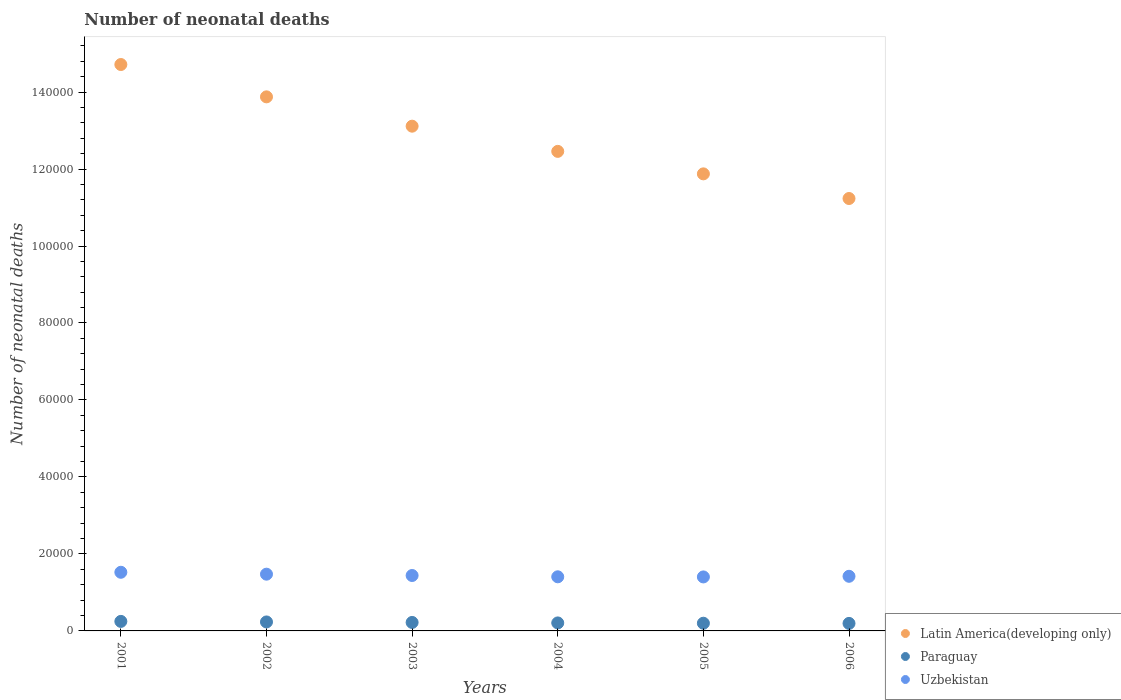How many different coloured dotlines are there?
Make the answer very short. 3. Is the number of dotlines equal to the number of legend labels?
Your answer should be compact. Yes. What is the number of neonatal deaths in in Latin America(developing only) in 2002?
Your answer should be very brief. 1.39e+05. Across all years, what is the maximum number of neonatal deaths in in Uzbekistan?
Your answer should be compact. 1.52e+04. Across all years, what is the minimum number of neonatal deaths in in Latin America(developing only)?
Keep it short and to the point. 1.12e+05. In which year was the number of neonatal deaths in in Paraguay minimum?
Offer a terse response. 2006. What is the total number of neonatal deaths in in Latin America(developing only) in the graph?
Provide a succinct answer. 7.73e+05. What is the difference between the number of neonatal deaths in in Paraguay in 2001 and that in 2002?
Your answer should be very brief. 142. What is the difference between the number of neonatal deaths in in Paraguay in 2003 and the number of neonatal deaths in in Latin America(developing only) in 2001?
Your response must be concise. -1.45e+05. What is the average number of neonatal deaths in in Paraguay per year?
Your answer should be very brief. 2172.33. In the year 2004, what is the difference between the number of neonatal deaths in in Paraguay and number of neonatal deaths in in Uzbekistan?
Offer a very short reply. -1.20e+04. What is the ratio of the number of neonatal deaths in in Latin America(developing only) in 2002 to that in 2006?
Provide a succinct answer. 1.24. Is the number of neonatal deaths in in Latin America(developing only) in 2004 less than that in 2006?
Give a very brief answer. No. Is the difference between the number of neonatal deaths in in Paraguay in 2002 and 2004 greater than the difference between the number of neonatal deaths in in Uzbekistan in 2002 and 2004?
Keep it short and to the point. No. What is the difference between the highest and the second highest number of neonatal deaths in in Uzbekistan?
Provide a short and direct response. 493. What is the difference between the highest and the lowest number of neonatal deaths in in Uzbekistan?
Make the answer very short. 1208. In how many years, is the number of neonatal deaths in in Uzbekistan greater than the average number of neonatal deaths in in Uzbekistan taken over all years?
Your answer should be compact. 2. Is the sum of the number of neonatal deaths in in Paraguay in 2005 and 2006 greater than the maximum number of neonatal deaths in in Latin America(developing only) across all years?
Your answer should be very brief. No. Is it the case that in every year, the sum of the number of neonatal deaths in in Uzbekistan and number of neonatal deaths in in Latin America(developing only)  is greater than the number of neonatal deaths in in Paraguay?
Make the answer very short. Yes. Is the number of neonatal deaths in in Paraguay strictly greater than the number of neonatal deaths in in Latin America(developing only) over the years?
Give a very brief answer. No. Is the number of neonatal deaths in in Uzbekistan strictly less than the number of neonatal deaths in in Paraguay over the years?
Make the answer very short. No. What is the difference between two consecutive major ticks on the Y-axis?
Keep it short and to the point. 2.00e+04. Where does the legend appear in the graph?
Provide a short and direct response. Bottom right. How are the legend labels stacked?
Offer a very short reply. Vertical. What is the title of the graph?
Make the answer very short. Number of neonatal deaths. What is the label or title of the X-axis?
Your answer should be compact. Years. What is the label or title of the Y-axis?
Your answer should be compact. Number of neonatal deaths. What is the Number of neonatal deaths of Latin America(developing only) in 2001?
Provide a short and direct response. 1.47e+05. What is the Number of neonatal deaths of Paraguay in 2001?
Ensure brevity in your answer.  2473. What is the Number of neonatal deaths of Uzbekistan in 2001?
Make the answer very short. 1.52e+04. What is the Number of neonatal deaths of Latin America(developing only) in 2002?
Your response must be concise. 1.39e+05. What is the Number of neonatal deaths of Paraguay in 2002?
Your answer should be compact. 2331. What is the Number of neonatal deaths in Uzbekistan in 2002?
Your answer should be compact. 1.47e+04. What is the Number of neonatal deaths of Latin America(developing only) in 2003?
Provide a succinct answer. 1.31e+05. What is the Number of neonatal deaths of Paraguay in 2003?
Your response must be concise. 2201. What is the Number of neonatal deaths of Uzbekistan in 2003?
Make the answer very short. 1.44e+04. What is the Number of neonatal deaths in Latin America(developing only) in 2004?
Keep it short and to the point. 1.25e+05. What is the Number of neonatal deaths of Paraguay in 2004?
Offer a terse response. 2077. What is the Number of neonatal deaths in Uzbekistan in 2004?
Make the answer very short. 1.41e+04. What is the Number of neonatal deaths of Latin America(developing only) in 2005?
Your response must be concise. 1.19e+05. What is the Number of neonatal deaths of Paraguay in 2005?
Keep it short and to the point. 1998. What is the Number of neonatal deaths of Uzbekistan in 2005?
Provide a succinct answer. 1.40e+04. What is the Number of neonatal deaths of Latin America(developing only) in 2006?
Provide a succinct answer. 1.12e+05. What is the Number of neonatal deaths in Paraguay in 2006?
Ensure brevity in your answer.  1954. What is the Number of neonatal deaths of Uzbekistan in 2006?
Provide a short and direct response. 1.42e+04. Across all years, what is the maximum Number of neonatal deaths in Latin America(developing only)?
Keep it short and to the point. 1.47e+05. Across all years, what is the maximum Number of neonatal deaths of Paraguay?
Ensure brevity in your answer.  2473. Across all years, what is the maximum Number of neonatal deaths of Uzbekistan?
Ensure brevity in your answer.  1.52e+04. Across all years, what is the minimum Number of neonatal deaths of Latin America(developing only)?
Offer a terse response. 1.12e+05. Across all years, what is the minimum Number of neonatal deaths in Paraguay?
Offer a very short reply. 1954. Across all years, what is the minimum Number of neonatal deaths in Uzbekistan?
Offer a very short reply. 1.40e+04. What is the total Number of neonatal deaths of Latin America(developing only) in the graph?
Give a very brief answer. 7.73e+05. What is the total Number of neonatal deaths in Paraguay in the graph?
Provide a succinct answer. 1.30e+04. What is the total Number of neonatal deaths in Uzbekistan in the graph?
Give a very brief answer. 8.67e+04. What is the difference between the Number of neonatal deaths of Latin America(developing only) in 2001 and that in 2002?
Give a very brief answer. 8401. What is the difference between the Number of neonatal deaths in Paraguay in 2001 and that in 2002?
Offer a terse response. 142. What is the difference between the Number of neonatal deaths of Uzbekistan in 2001 and that in 2002?
Your answer should be compact. 493. What is the difference between the Number of neonatal deaths of Latin America(developing only) in 2001 and that in 2003?
Provide a succinct answer. 1.60e+04. What is the difference between the Number of neonatal deaths in Paraguay in 2001 and that in 2003?
Your answer should be very brief. 272. What is the difference between the Number of neonatal deaths in Uzbekistan in 2001 and that in 2003?
Your answer should be very brief. 838. What is the difference between the Number of neonatal deaths in Latin America(developing only) in 2001 and that in 2004?
Ensure brevity in your answer.  2.26e+04. What is the difference between the Number of neonatal deaths of Paraguay in 2001 and that in 2004?
Ensure brevity in your answer.  396. What is the difference between the Number of neonatal deaths of Uzbekistan in 2001 and that in 2004?
Your response must be concise. 1176. What is the difference between the Number of neonatal deaths in Latin America(developing only) in 2001 and that in 2005?
Your answer should be very brief. 2.84e+04. What is the difference between the Number of neonatal deaths of Paraguay in 2001 and that in 2005?
Your answer should be compact. 475. What is the difference between the Number of neonatal deaths of Uzbekistan in 2001 and that in 2005?
Your answer should be compact. 1208. What is the difference between the Number of neonatal deaths of Latin America(developing only) in 2001 and that in 2006?
Offer a terse response. 3.48e+04. What is the difference between the Number of neonatal deaths in Paraguay in 2001 and that in 2006?
Offer a terse response. 519. What is the difference between the Number of neonatal deaths in Uzbekistan in 2001 and that in 2006?
Keep it short and to the point. 1044. What is the difference between the Number of neonatal deaths of Latin America(developing only) in 2002 and that in 2003?
Your response must be concise. 7619. What is the difference between the Number of neonatal deaths in Paraguay in 2002 and that in 2003?
Keep it short and to the point. 130. What is the difference between the Number of neonatal deaths of Uzbekistan in 2002 and that in 2003?
Make the answer very short. 345. What is the difference between the Number of neonatal deaths of Latin America(developing only) in 2002 and that in 2004?
Keep it short and to the point. 1.42e+04. What is the difference between the Number of neonatal deaths in Paraguay in 2002 and that in 2004?
Offer a very short reply. 254. What is the difference between the Number of neonatal deaths of Uzbekistan in 2002 and that in 2004?
Give a very brief answer. 683. What is the difference between the Number of neonatal deaths in Latin America(developing only) in 2002 and that in 2005?
Provide a short and direct response. 2.00e+04. What is the difference between the Number of neonatal deaths of Paraguay in 2002 and that in 2005?
Your response must be concise. 333. What is the difference between the Number of neonatal deaths in Uzbekistan in 2002 and that in 2005?
Your answer should be very brief. 715. What is the difference between the Number of neonatal deaths in Latin America(developing only) in 2002 and that in 2006?
Offer a very short reply. 2.64e+04. What is the difference between the Number of neonatal deaths of Paraguay in 2002 and that in 2006?
Your answer should be compact. 377. What is the difference between the Number of neonatal deaths of Uzbekistan in 2002 and that in 2006?
Offer a terse response. 551. What is the difference between the Number of neonatal deaths in Latin America(developing only) in 2003 and that in 2004?
Ensure brevity in your answer.  6545. What is the difference between the Number of neonatal deaths in Paraguay in 2003 and that in 2004?
Provide a short and direct response. 124. What is the difference between the Number of neonatal deaths in Uzbekistan in 2003 and that in 2004?
Give a very brief answer. 338. What is the difference between the Number of neonatal deaths of Latin America(developing only) in 2003 and that in 2005?
Make the answer very short. 1.24e+04. What is the difference between the Number of neonatal deaths of Paraguay in 2003 and that in 2005?
Offer a very short reply. 203. What is the difference between the Number of neonatal deaths in Uzbekistan in 2003 and that in 2005?
Offer a terse response. 370. What is the difference between the Number of neonatal deaths of Latin America(developing only) in 2003 and that in 2006?
Offer a terse response. 1.88e+04. What is the difference between the Number of neonatal deaths of Paraguay in 2003 and that in 2006?
Provide a succinct answer. 247. What is the difference between the Number of neonatal deaths in Uzbekistan in 2003 and that in 2006?
Your answer should be compact. 206. What is the difference between the Number of neonatal deaths of Latin America(developing only) in 2004 and that in 2005?
Provide a succinct answer. 5842. What is the difference between the Number of neonatal deaths in Paraguay in 2004 and that in 2005?
Provide a short and direct response. 79. What is the difference between the Number of neonatal deaths of Latin America(developing only) in 2004 and that in 2006?
Provide a succinct answer. 1.22e+04. What is the difference between the Number of neonatal deaths in Paraguay in 2004 and that in 2006?
Your answer should be compact. 123. What is the difference between the Number of neonatal deaths in Uzbekistan in 2004 and that in 2006?
Your answer should be compact. -132. What is the difference between the Number of neonatal deaths in Latin America(developing only) in 2005 and that in 2006?
Make the answer very short. 6403. What is the difference between the Number of neonatal deaths of Paraguay in 2005 and that in 2006?
Offer a very short reply. 44. What is the difference between the Number of neonatal deaths in Uzbekistan in 2005 and that in 2006?
Offer a terse response. -164. What is the difference between the Number of neonatal deaths in Latin America(developing only) in 2001 and the Number of neonatal deaths in Paraguay in 2002?
Your response must be concise. 1.45e+05. What is the difference between the Number of neonatal deaths of Latin America(developing only) in 2001 and the Number of neonatal deaths of Uzbekistan in 2002?
Provide a succinct answer. 1.32e+05. What is the difference between the Number of neonatal deaths of Paraguay in 2001 and the Number of neonatal deaths of Uzbekistan in 2002?
Offer a very short reply. -1.23e+04. What is the difference between the Number of neonatal deaths of Latin America(developing only) in 2001 and the Number of neonatal deaths of Paraguay in 2003?
Your answer should be compact. 1.45e+05. What is the difference between the Number of neonatal deaths of Latin America(developing only) in 2001 and the Number of neonatal deaths of Uzbekistan in 2003?
Your answer should be very brief. 1.33e+05. What is the difference between the Number of neonatal deaths of Paraguay in 2001 and the Number of neonatal deaths of Uzbekistan in 2003?
Make the answer very short. -1.19e+04. What is the difference between the Number of neonatal deaths in Latin America(developing only) in 2001 and the Number of neonatal deaths in Paraguay in 2004?
Offer a very short reply. 1.45e+05. What is the difference between the Number of neonatal deaths of Latin America(developing only) in 2001 and the Number of neonatal deaths of Uzbekistan in 2004?
Offer a terse response. 1.33e+05. What is the difference between the Number of neonatal deaths in Paraguay in 2001 and the Number of neonatal deaths in Uzbekistan in 2004?
Provide a succinct answer. -1.16e+04. What is the difference between the Number of neonatal deaths in Latin America(developing only) in 2001 and the Number of neonatal deaths in Paraguay in 2005?
Your answer should be compact. 1.45e+05. What is the difference between the Number of neonatal deaths of Latin America(developing only) in 2001 and the Number of neonatal deaths of Uzbekistan in 2005?
Give a very brief answer. 1.33e+05. What is the difference between the Number of neonatal deaths in Paraguay in 2001 and the Number of neonatal deaths in Uzbekistan in 2005?
Your answer should be compact. -1.16e+04. What is the difference between the Number of neonatal deaths of Latin America(developing only) in 2001 and the Number of neonatal deaths of Paraguay in 2006?
Give a very brief answer. 1.45e+05. What is the difference between the Number of neonatal deaths in Latin America(developing only) in 2001 and the Number of neonatal deaths in Uzbekistan in 2006?
Keep it short and to the point. 1.33e+05. What is the difference between the Number of neonatal deaths of Paraguay in 2001 and the Number of neonatal deaths of Uzbekistan in 2006?
Make the answer very short. -1.17e+04. What is the difference between the Number of neonatal deaths in Latin America(developing only) in 2002 and the Number of neonatal deaths in Paraguay in 2003?
Your response must be concise. 1.37e+05. What is the difference between the Number of neonatal deaths of Latin America(developing only) in 2002 and the Number of neonatal deaths of Uzbekistan in 2003?
Your answer should be very brief. 1.24e+05. What is the difference between the Number of neonatal deaths in Paraguay in 2002 and the Number of neonatal deaths in Uzbekistan in 2003?
Make the answer very short. -1.21e+04. What is the difference between the Number of neonatal deaths in Latin America(developing only) in 2002 and the Number of neonatal deaths in Paraguay in 2004?
Provide a succinct answer. 1.37e+05. What is the difference between the Number of neonatal deaths in Latin America(developing only) in 2002 and the Number of neonatal deaths in Uzbekistan in 2004?
Make the answer very short. 1.25e+05. What is the difference between the Number of neonatal deaths of Paraguay in 2002 and the Number of neonatal deaths of Uzbekistan in 2004?
Provide a short and direct response. -1.17e+04. What is the difference between the Number of neonatal deaths of Latin America(developing only) in 2002 and the Number of neonatal deaths of Paraguay in 2005?
Keep it short and to the point. 1.37e+05. What is the difference between the Number of neonatal deaths in Latin America(developing only) in 2002 and the Number of neonatal deaths in Uzbekistan in 2005?
Make the answer very short. 1.25e+05. What is the difference between the Number of neonatal deaths of Paraguay in 2002 and the Number of neonatal deaths of Uzbekistan in 2005?
Provide a succinct answer. -1.17e+04. What is the difference between the Number of neonatal deaths in Latin America(developing only) in 2002 and the Number of neonatal deaths in Paraguay in 2006?
Give a very brief answer. 1.37e+05. What is the difference between the Number of neonatal deaths in Latin America(developing only) in 2002 and the Number of neonatal deaths in Uzbekistan in 2006?
Ensure brevity in your answer.  1.25e+05. What is the difference between the Number of neonatal deaths of Paraguay in 2002 and the Number of neonatal deaths of Uzbekistan in 2006?
Make the answer very short. -1.19e+04. What is the difference between the Number of neonatal deaths of Latin America(developing only) in 2003 and the Number of neonatal deaths of Paraguay in 2004?
Your answer should be very brief. 1.29e+05. What is the difference between the Number of neonatal deaths in Latin America(developing only) in 2003 and the Number of neonatal deaths in Uzbekistan in 2004?
Keep it short and to the point. 1.17e+05. What is the difference between the Number of neonatal deaths in Paraguay in 2003 and the Number of neonatal deaths in Uzbekistan in 2004?
Your answer should be compact. -1.19e+04. What is the difference between the Number of neonatal deaths of Latin America(developing only) in 2003 and the Number of neonatal deaths of Paraguay in 2005?
Keep it short and to the point. 1.29e+05. What is the difference between the Number of neonatal deaths of Latin America(developing only) in 2003 and the Number of neonatal deaths of Uzbekistan in 2005?
Your answer should be very brief. 1.17e+05. What is the difference between the Number of neonatal deaths in Paraguay in 2003 and the Number of neonatal deaths in Uzbekistan in 2005?
Your answer should be very brief. -1.18e+04. What is the difference between the Number of neonatal deaths in Latin America(developing only) in 2003 and the Number of neonatal deaths in Paraguay in 2006?
Keep it short and to the point. 1.29e+05. What is the difference between the Number of neonatal deaths of Latin America(developing only) in 2003 and the Number of neonatal deaths of Uzbekistan in 2006?
Ensure brevity in your answer.  1.17e+05. What is the difference between the Number of neonatal deaths of Paraguay in 2003 and the Number of neonatal deaths of Uzbekistan in 2006?
Make the answer very short. -1.20e+04. What is the difference between the Number of neonatal deaths in Latin America(developing only) in 2004 and the Number of neonatal deaths in Paraguay in 2005?
Your response must be concise. 1.23e+05. What is the difference between the Number of neonatal deaths of Latin America(developing only) in 2004 and the Number of neonatal deaths of Uzbekistan in 2005?
Offer a very short reply. 1.11e+05. What is the difference between the Number of neonatal deaths of Paraguay in 2004 and the Number of neonatal deaths of Uzbekistan in 2005?
Offer a very short reply. -1.20e+04. What is the difference between the Number of neonatal deaths in Latin America(developing only) in 2004 and the Number of neonatal deaths in Paraguay in 2006?
Make the answer very short. 1.23e+05. What is the difference between the Number of neonatal deaths in Latin America(developing only) in 2004 and the Number of neonatal deaths in Uzbekistan in 2006?
Offer a terse response. 1.10e+05. What is the difference between the Number of neonatal deaths in Paraguay in 2004 and the Number of neonatal deaths in Uzbekistan in 2006?
Give a very brief answer. -1.21e+04. What is the difference between the Number of neonatal deaths in Latin America(developing only) in 2005 and the Number of neonatal deaths in Paraguay in 2006?
Make the answer very short. 1.17e+05. What is the difference between the Number of neonatal deaths in Latin America(developing only) in 2005 and the Number of neonatal deaths in Uzbekistan in 2006?
Your answer should be very brief. 1.05e+05. What is the difference between the Number of neonatal deaths of Paraguay in 2005 and the Number of neonatal deaths of Uzbekistan in 2006?
Offer a terse response. -1.22e+04. What is the average Number of neonatal deaths of Latin America(developing only) per year?
Ensure brevity in your answer.  1.29e+05. What is the average Number of neonatal deaths of Paraguay per year?
Give a very brief answer. 2172.33. What is the average Number of neonatal deaths of Uzbekistan per year?
Provide a short and direct response. 1.44e+04. In the year 2001, what is the difference between the Number of neonatal deaths of Latin America(developing only) and Number of neonatal deaths of Paraguay?
Offer a terse response. 1.45e+05. In the year 2001, what is the difference between the Number of neonatal deaths in Latin America(developing only) and Number of neonatal deaths in Uzbekistan?
Your answer should be compact. 1.32e+05. In the year 2001, what is the difference between the Number of neonatal deaths in Paraguay and Number of neonatal deaths in Uzbekistan?
Make the answer very short. -1.28e+04. In the year 2002, what is the difference between the Number of neonatal deaths in Latin America(developing only) and Number of neonatal deaths in Paraguay?
Offer a very short reply. 1.36e+05. In the year 2002, what is the difference between the Number of neonatal deaths of Latin America(developing only) and Number of neonatal deaths of Uzbekistan?
Your response must be concise. 1.24e+05. In the year 2002, what is the difference between the Number of neonatal deaths of Paraguay and Number of neonatal deaths of Uzbekistan?
Offer a very short reply. -1.24e+04. In the year 2003, what is the difference between the Number of neonatal deaths in Latin America(developing only) and Number of neonatal deaths in Paraguay?
Give a very brief answer. 1.29e+05. In the year 2003, what is the difference between the Number of neonatal deaths of Latin America(developing only) and Number of neonatal deaths of Uzbekistan?
Keep it short and to the point. 1.17e+05. In the year 2003, what is the difference between the Number of neonatal deaths in Paraguay and Number of neonatal deaths in Uzbekistan?
Give a very brief answer. -1.22e+04. In the year 2004, what is the difference between the Number of neonatal deaths of Latin America(developing only) and Number of neonatal deaths of Paraguay?
Keep it short and to the point. 1.23e+05. In the year 2004, what is the difference between the Number of neonatal deaths of Latin America(developing only) and Number of neonatal deaths of Uzbekistan?
Make the answer very short. 1.11e+05. In the year 2004, what is the difference between the Number of neonatal deaths in Paraguay and Number of neonatal deaths in Uzbekistan?
Provide a succinct answer. -1.20e+04. In the year 2005, what is the difference between the Number of neonatal deaths of Latin America(developing only) and Number of neonatal deaths of Paraguay?
Your answer should be compact. 1.17e+05. In the year 2005, what is the difference between the Number of neonatal deaths of Latin America(developing only) and Number of neonatal deaths of Uzbekistan?
Your answer should be very brief. 1.05e+05. In the year 2005, what is the difference between the Number of neonatal deaths in Paraguay and Number of neonatal deaths in Uzbekistan?
Offer a terse response. -1.20e+04. In the year 2006, what is the difference between the Number of neonatal deaths of Latin America(developing only) and Number of neonatal deaths of Paraguay?
Offer a very short reply. 1.10e+05. In the year 2006, what is the difference between the Number of neonatal deaths in Latin America(developing only) and Number of neonatal deaths in Uzbekistan?
Your response must be concise. 9.82e+04. In the year 2006, what is the difference between the Number of neonatal deaths in Paraguay and Number of neonatal deaths in Uzbekistan?
Offer a very short reply. -1.22e+04. What is the ratio of the Number of neonatal deaths of Latin America(developing only) in 2001 to that in 2002?
Provide a short and direct response. 1.06. What is the ratio of the Number of neonatal deaths in Paraguay in 2001 to that in 2002?
Offer a very short reply. 1.06. What is the ratio of the Number of neonatal deaths in Uzbekistan in 2001 to that in 2002?
Make the answer very short. 1.03. What is the ratio of the Number of neonatal deaths of Latin America(developing only) in 2001 to that in 2003?
Your response must be concise. 1.12. What is the ratio of the Number of neonatal deaths in Paraguay in 2001 to that in 2003?
Make the answer very short. 1.12. What is the ratio of the Number of neonatal deaths of Uzbekistan in 2001 to that in 2003?
Your response must be concise. 1.06. What is the ratio of the Number of neonatal deaths in Latin America(developing only) in 2001 to that in 2004?
Keep it short and to the point. 1.18. What is the ratio of the Number of neonatal deaths in Paraguay in 2001 to that in 2004?
Keep it short and to the point. 1.19. What is the ratio of the Number of neonatal deaths in Uzbekistan in 2001 to that in 2004?
Offer a terse response. 1.08. What is the ratio of the Number of neonatal deaths of Latin America(developing only) in 2001 to that in 2005?
Offer a very short reply. 1.24. What is the ratio of the Number of neonatal deaths of Paraguay in 2001 to that in 2005?
Your answer should be very brief. 1.24. What is the ratio of the Number of neonatal deaths of Uzbekistan in 2001 to that in 2005?
Ensure brevity in your answer.  1.09. What is the ratio of the Number of neonatal deaths in Latin America(developing only) in 2001 to that in 2006?
Offer a very short reply. 1.31. What is the ratio of the Number of neonatal deaths of Paraguay in 2001 to that in 2006?
Provide a succinct answer. 1.27. What is the ratio of the Number of neonatal deaths of Uzbekistan in 2001 to that in 2006?
Offer a terse response. 1.07. What is the ratio of the Number of neonatal deaths in Latin America(developing only) in 2002 to that in 2003?
Provide a short and direct response. 1.06. What is the ratio of the Number of neonatal deaths of Paraguay in 2002 to that in 2003?
Offer a terse response. 1.06. What is the ratio of the Number of neonatal deaths of Latin America(developing only) in 2002 to that in 2004?
Keep it short and to the point. 1.11. What is the ratio of the Number of neonatal deaths in Paraguay in 2002 to that in 2004?
Offer a terse response. 1.12. What is the ratio of the Number of neonatal deaths in Uzbekistan in 2002 to that in 2004?
Provide a succinct answer. 1.05. What is the ratio of the Number of neonatal deaths in Latin America(developing only) in 2002 to that in 2005?
Your answer should be very brief. 1.17. What is the ratio of the Number of neonatal deaths in Uzbekistan in 2002 to that in 2005?
Provide a succinct answer. 1.05. What is the ratio of the Number of neonatal deaths in Latin America(developing only) in 2002 to that in 2006?
Your answer should be compact. 1.24. What is the ratio of the Number of neonatal deaths in Paraguay in 2002 to that in 2006?
Make the answer very short. 1.19. What is the ratio of the Number of neonatal deaths in Uzbekistan in 2002 to that in 2006?
Provide a short and direct response. 1.04. What is the ratio of the Number of neonatal deaths in Latin America(developing only) in 2003 to that in 2004?
Keep it short and to the point. 1.05. What is the ratio of the Number of neonatal deaths of Paraguay in 2003 to that in 2004?
Give a very brief answer. 1.06. What is the ratio of the Number of neonatal deaths in Latin America(developing only) in 2003 to that in 2005?
Your response must be concise. 1.1. What is the ratio of the Number of neonatal deaths of Paraguay in 2003 to that in 2005?
Provide a short and direct response. 1.1. What is the ratio of the Number of neonatal deaths of Uzbekistan in 2003 to that in 2005?
Provide a short and direct response. 1.03. What is the ratio of the Number of neonatal deaths of Latin America(developing only) in 2003 to that in 2006?
Provide a succinct answer. 1.17. What is the ratio of the Number of neonatal deaths of Paraguay in 2003 to that in 2006?
Ensure brevity in your answer.  1.13. What is the ratio of the Number of neonatal deaths in Uzbekistan in 2003 to that in 2006?
Your answer should be compact. 1.01. What is the ratio of the Number of neonatal deaths in Latin America(developing only) in 2004 to that in 2005?
Your answer should be very brief. 1.05. What is the ratio of the Number of neonatal deaths in Paraguay in 2004 to that in 2005?
Make the answer very short. 1.04. What is the ratio of the Number of neonatal deaths of Latin America(developing only) in 2004 to that in 2006?
Give a very brief answer. 1.11. What is the ratio of the Number of neonatal deaths of Paraguay in 2004 to that in 2006?
Your answer should be compact. 1.06. What is the ratio of the Number of neonatal deaths of Uzbekistan in 2004 to that in 2006?
Offer a very short reply. 0.99. What is the ratio of the Number of neonatal deaths in Latin America(developing only) in 2005 to that in 2006?
Offer a terse response. 1.06. What is the ratio of the Number of neonatal deaths in Paraguay in 2005 to that in 2006?
Keep it short and to the point. 1.02. What is the ratio of the Number of neonatal deaths in Uzbekistan in 2005 to that in 2006?
Your answer should be compact. 0.99. What is the difference between the highest and the second highest Number of neonatal deaths in Latin America(developing only)?
Provide a short and direct response. 8401. What is the difference between the highest and the second highest Number of neonatal deaths of Paraguay?
Give a very brief answer. 142. What is the difference between the highest and the second highest Number of neonatal deaths in Uzbekistan?
Provide a succinct answer. 493. What is the difference between the highest and the lowest Number of neonatal deaths of Latin America(developing only)?
Keep it short and to the point. 3.48e+04. What is the difference between the highest and the lowest Number of neonatal deaths of Paraguay?
Offer a terse response. 519. What is the difference between the highest and the lowest Number of neonatal deaths of Uzbekistan?
Make the answer very short. 1208. 